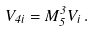Convert formula to latex. <formula><loc_0><loc_0><loc_500><loc_500>V _ { 4 i } = M _ { 5 } ^ { 3 } V _ { i } \, .</formula> 